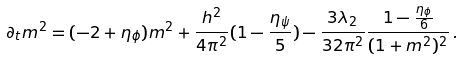Convert formula to latex. <formula><loc_0><loc_0><loc_500><loc_500>\partial _ { t } m ^ { 2 } = ( - 2 + \eta _ { \phi } ) m ^ { 2 } + \frac { h ^ { 2 } } { 4 \pi ^ { 2 } } ( 1 - \frac { \eta _ { \psi } } { 5 } ) - \frac { 3 \lambda _ { 2 } } { 3 2 \pi ^ { 2 } } \frac { 1 - \frac { \eta _ { \phi } } { 6 } } { ( 1 + m ^ { 2 } ) ^ { 2 } } \, .</formula> 